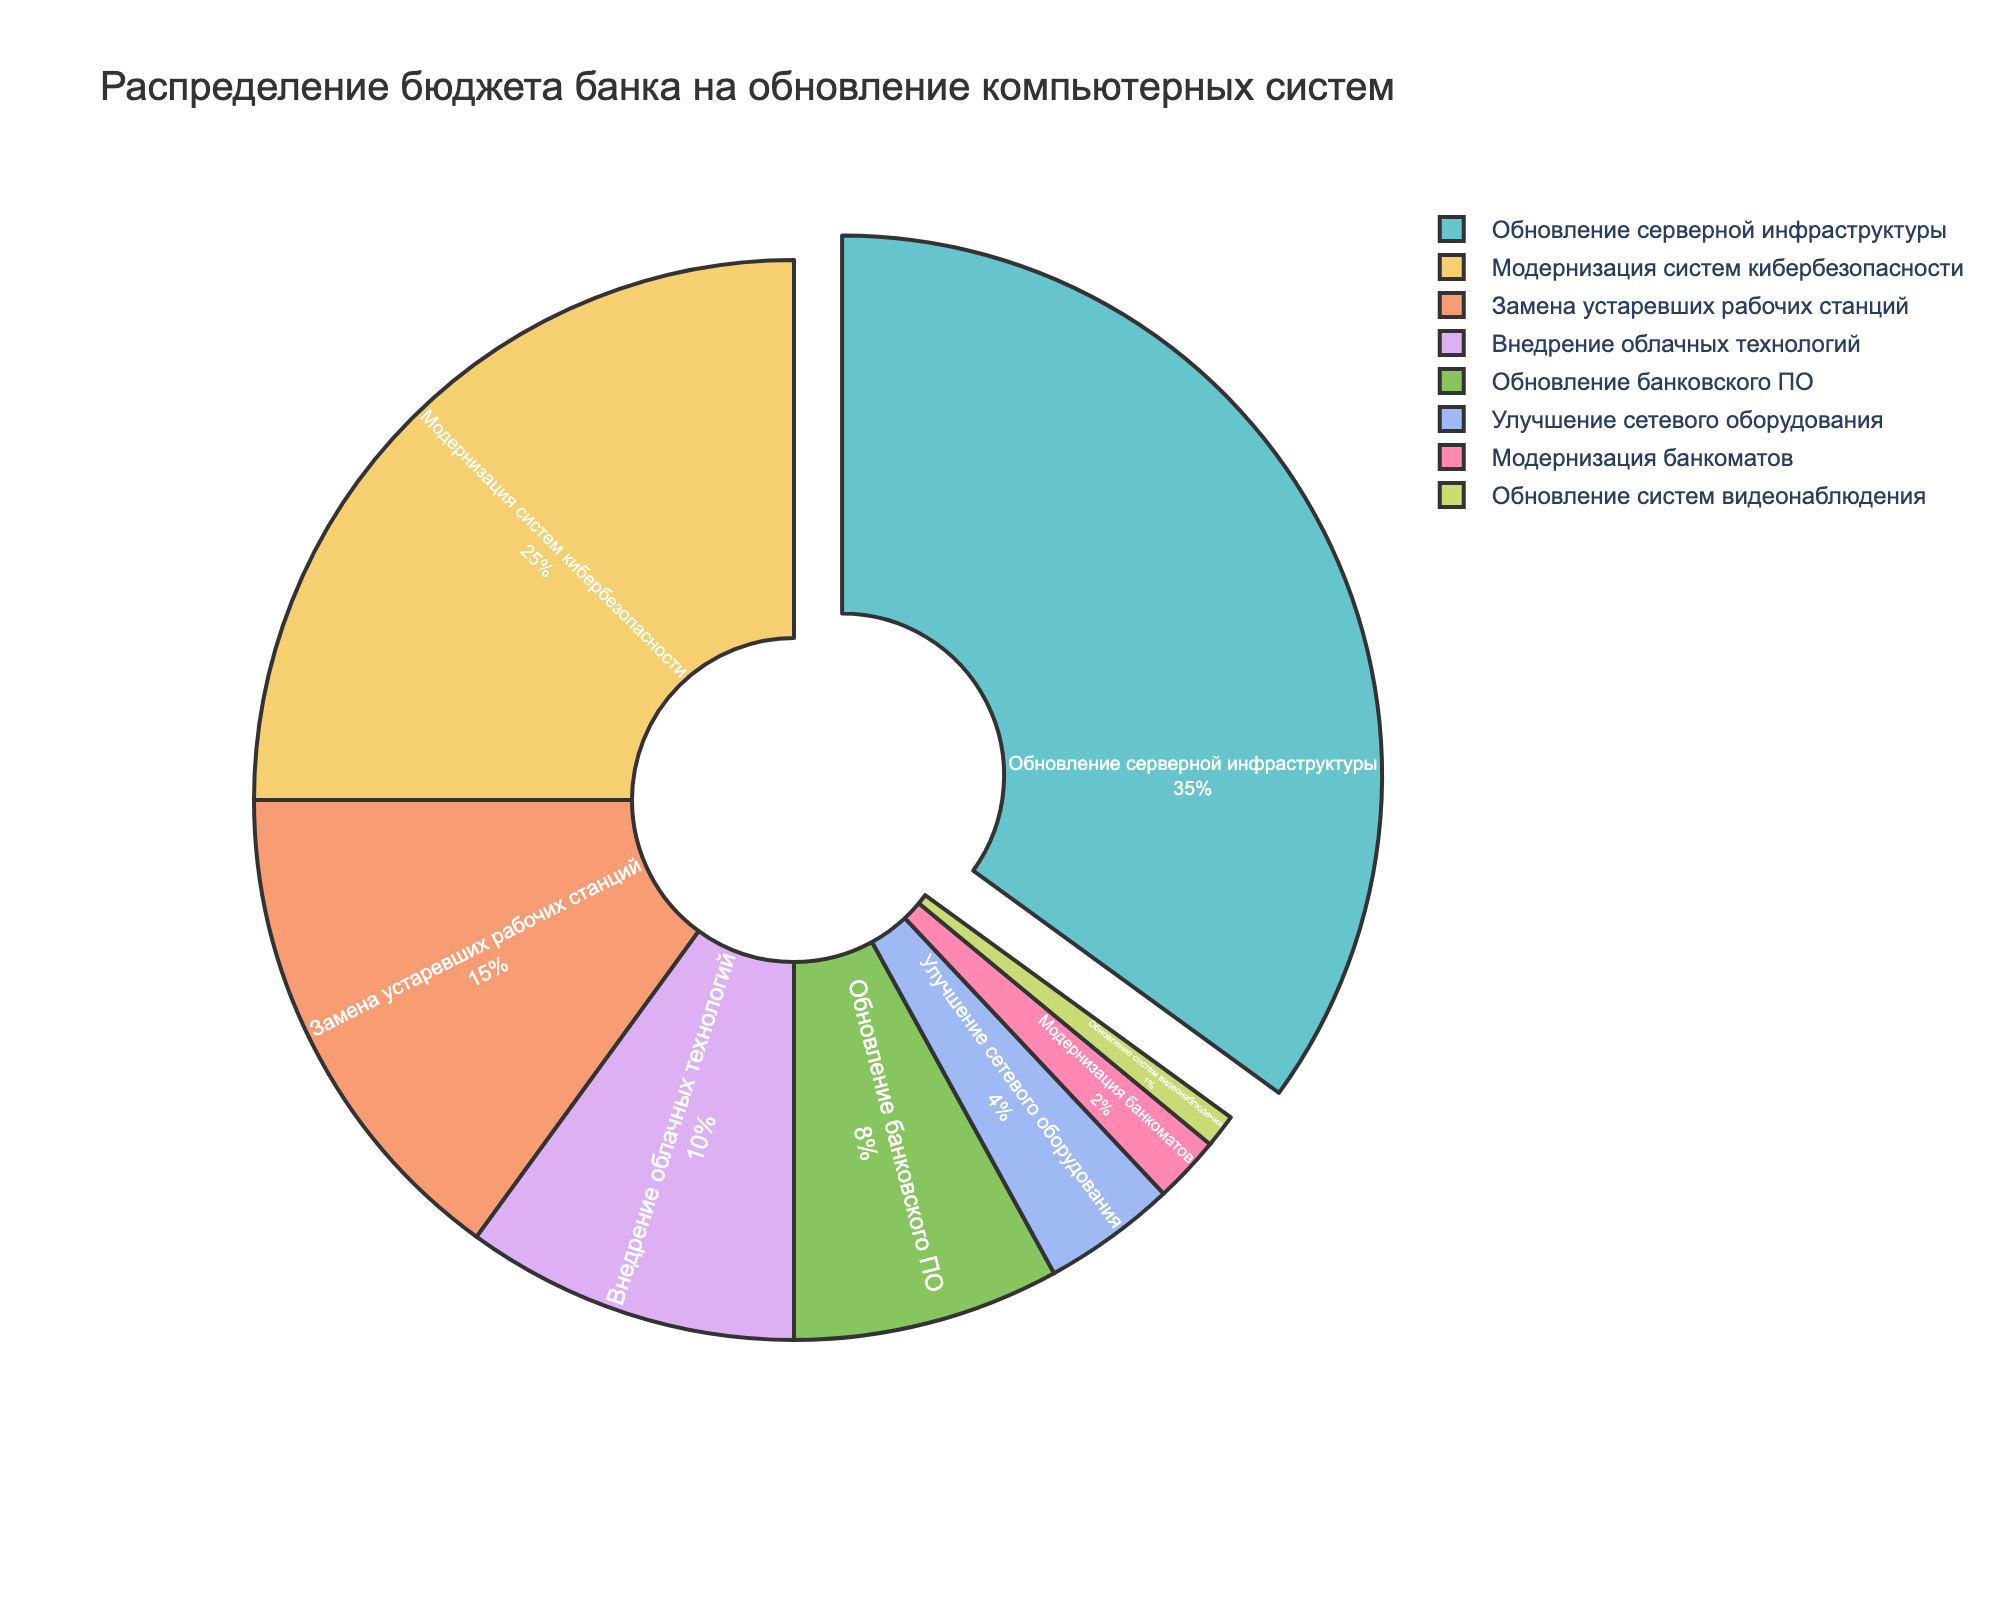Which system has the highest percentage of budget allocation? The pie chart shows that "Обновление серверной инфраструктуры" has the largest segment, indicating it has the highest percentage of budget allocation.
Answer: Обновление серверной инфраструктуры What is the combined budget percentage for the systems related to security (кибербезопасности and видеонаблюдения)? Add the percentages for "Модернизация систем кибербезопасности" (25%) and "Обновление систем видеонаблюдения" (1%). So, 25% + 1% = 26%.
Answer: 26% Is the budget for модернизация банкоматов greater than or less than that for улучшение сетевого оборудования? The pie chart shows that "Модернизация банкоматов" has 2% of the budget, while "Улучшение сетевого оборудования" has 4%. Thus, 2% is less than 4%.
Answer: Less What is the difference in budget allocation between обновление банковского ПО and внедрение облачных технологий? The budget for "Обновление банковского ПО" is 8% and for "Внедрение облачных технологий" it is 10%. The difference is 10% - 8% = 2%.
Answer: 2% How many systems have a budget allocation greater than 10%? The pie chart shows that only two systems, "Обновление серверной инфраструктуры" (35%) and "Модернизация систем кибербезопасности" (25%), have allocations greater than 10%.
Answer: 2 What percentage of the budget is allocated to replacing устаревших рабочих станций and модернизация банкоматов combined? Add the percentages for "Замена устаревших рабочих станций" (15%) and "Модернизация банкоматов" (2%). So, 15% + 2% = 17%.
Answer: 17% Which system has the smallest budget allocation, and what is its percentage? The pie chart shows that "Обновление систем видеонаблюдения" has the smallest segment, indicating it has the smallest budget allocation of 1%.
Answer: Обновление систем видеонаблюдения, 1% What is the average budget allocation for all systems? Add up the percentages for all systems (35 + 25 + 15 + 10 + 8 + 4 + 2 + 1 = 100), then divide by the number of systems (8). The average is 100 / 8 = 12.5%.
Answer: 12.5% Is the budget for each of the top two systems collectively more than half of the total budget? The top two systems are "Обновление серверной инфраструктуры" (35%) and "Модернизация систем кибербезопасности" (25%). Their combined budget is 35% + 25% = 60%, which is more than half of the total budget.
Answer: Yes 